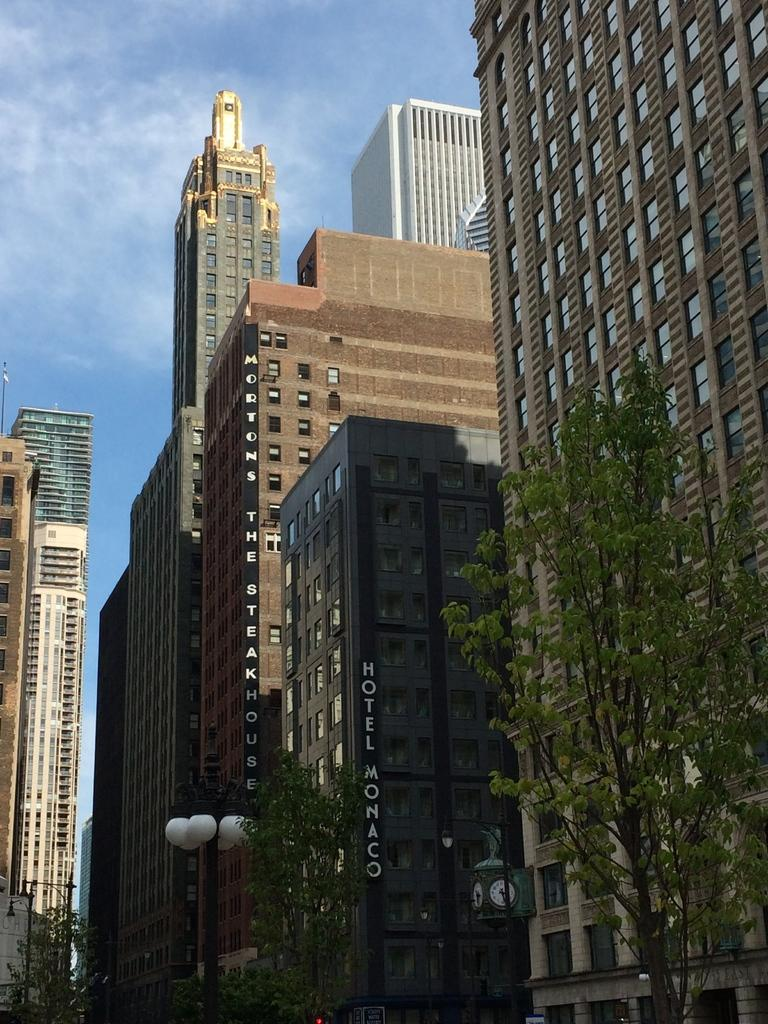What type of structures can be seen in the image? There are buildings in the image. What other natural elements are present in the image? There are trees in the image. Are there any artificial light sources visible in the image? Yes, there are lights visible in the image. What is the color of the sky in the image? The sky is blue in the image. What type of circle can be seen in the image? There is no circle present in the image. What is the mode of transportation for the journey depicted in the image? There is no journey depicted in the image. 